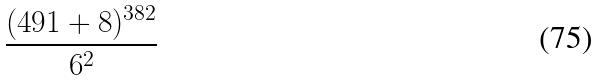<formula> <loc_0><loc_0><loc_500><loc_500>\frac { ( 4 9 1 + 8 ) ^ { 3 8 2 } } { 6 ^ { 2 } }</formula> 